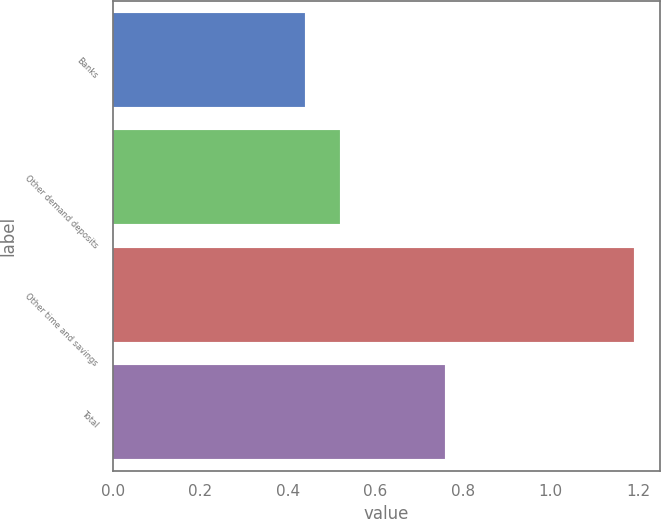Convert chart. <chart><loc_0><loc_0><loc_500><loc_500><bar_chart><fcel>Banks<fcel>Other demand deposits<fcel>Other time and savings<fcel>Total<nl><fcel>0.44<fcel>0.52<fcel>1.19<fcel>0.76<nl></chart> 